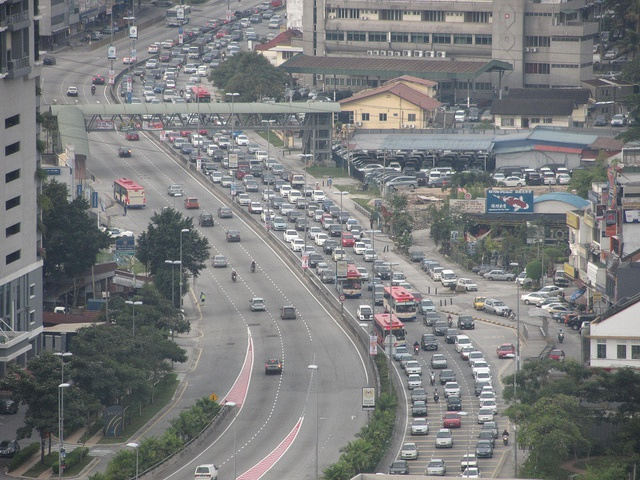Describe the objects in this image and their specific colors. I can see car in darkgray, gray, and lightgray tones, bus in darkgray, gray, lightpink, and brown tones, bus in darkgray, gray, lightpink, and brown tones, bus in darkgray, gray, and pink tones, and bus in darkgray, gray, and pink tones in this image. 